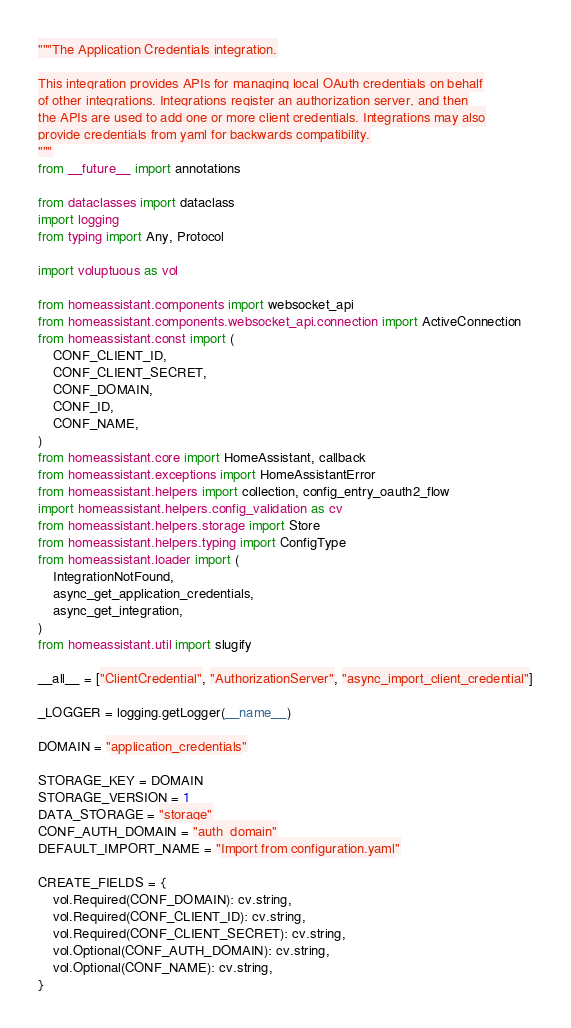Convert code to text. <code><loc_0><loc_0><loc_500><loc_500><_Python_>"""The Application Credentials integration.

This integration provides APIs for managing local OAuth credentials on behalf
of other integrations. Integrations register an authorization server, and then
the APIs are used to add one or more client credentials. Integrations may also
provide credentials from yaml for backwards compatibility.
"""
from __future__ import annotations

from dataclasses import dataclass
import logging
from typing import Any, Protocol

import voluptuous as vol

from homeassistant.components import websocket_api
from homeassistant.components.websocket_api.connection import ActiveConnection
from homeassistant.const import (
    CONF_CLIENT_ID,
    CONF_CLIENT_SECRET,
    CONF_DOMAIN,
    CONF_ID,
    CONF_NAME,
)
from homeassistant.core import HomeAssistant, callback
from homeassistant.exceptions import HomeAssistantError
from homeassistant.helpers import collection, config_entry_oauth2_flow
import homeassistant.helpers.config_validation as cv
from homeassistant.helpers.storage import Store
from homeassistant.helpers.typing import ConfigType
from homeassistant.loader import (
    IntegrationNotFound,
    async_get_application_credentials,
    async_get_integration,
)
from homeassistant.util import slugify

__all__ = ["ClientCredential", "AuthorizationServer", "async_import_client_credential"]

_LOGGER = logging.getLogger(__name__)

DOMAIN = "application_credentials"

STORAGE_KEY = DOMAIN
STORAGE_VERSION = 1
DATA_STORAGE = "storage"
CONF_AUTH_DOMAIN = "auth_domain"
DEFAULT_IMPORT_NAME = "Import from configuration.yaml"

CREATE_FIELDS = {
    vol.Required(CONF_DOMAIN): cv.string,
    vol.Required(CONF_CLIENT_ID): cv.string,
    vol.Required(CONF_CLIENT_SECRET): cv.string,
    vol.Optional(CONF_AUTH_DOMAIN): cv.string,
    vol.Optional(CONF_NAME): cv.string,
}</code> 